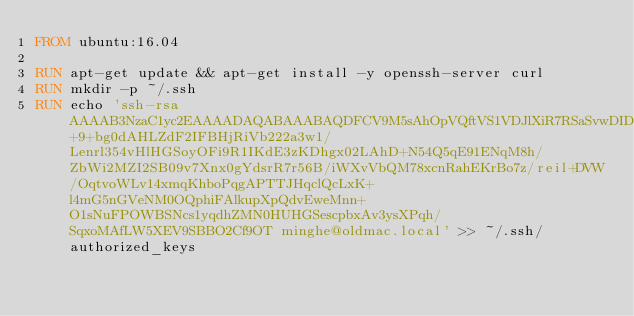Convert code to text. <code><loc_0><loc_0><loc_500><loc_500><_Dockerfile_>FROM ubuntu:16.04

RUN apt-get update && apt-get install -y openssh-server curl
RUN mkdir -p ~/.ssh
RUN echo 'ssh-rsa AAAAB3NzaC1yc2EAAAADAQABAAABAQDFCV9M5sAhOpVQftVS1VDJlXiR7RSaSvwDIDrSoB1Kgz7C60YmRVA+9+bg0dAHLZdF2IFBHjRiVb222a3w1/Lenrl354vHlHGSoyOFi9R1IKdE3zKDhgx02LAhD+N54Q5qE91ENqM8h/ZbWi2MZI2SB09v7Xnx0gYdsrR7r56B/iWXvVbQM78xcnRahEKrBo7z/reil+DVW/OqtvoWLv14xmqKhboPqgAPTTJHqclQcLxK+l4mG5nGVeNM0OQphiFAlkupXpQdvEweMnn+O1sNuFPOWBSNcs1yqdhZMN0HUHGSescpbxAv3ysXPqh/SqxoMAfLW5XEV9SBBO2Cf9OT minghe@oldmac.local' >> ~/.ssh/authorized_keys</code> 